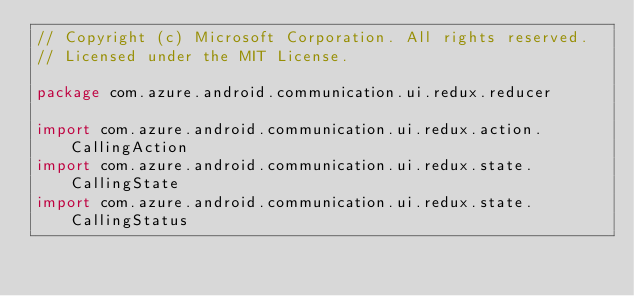Convert code to text. <code><loc_0><loc_0><loc_500><loc_500><_Kotlin_>// Copyright (c) Microsoft Corporation. All rights reserved.
// Licensed under the MIT License.

package com.azure.android.communication.ui.redux.reducer

import com.azure.android.communication.ui.redux.action.CallingAction
import com.azure.android.communication.ui.redux.state.CallingState
import com.azure.android.communication.ui.redux.state.CallingStatus</code> 